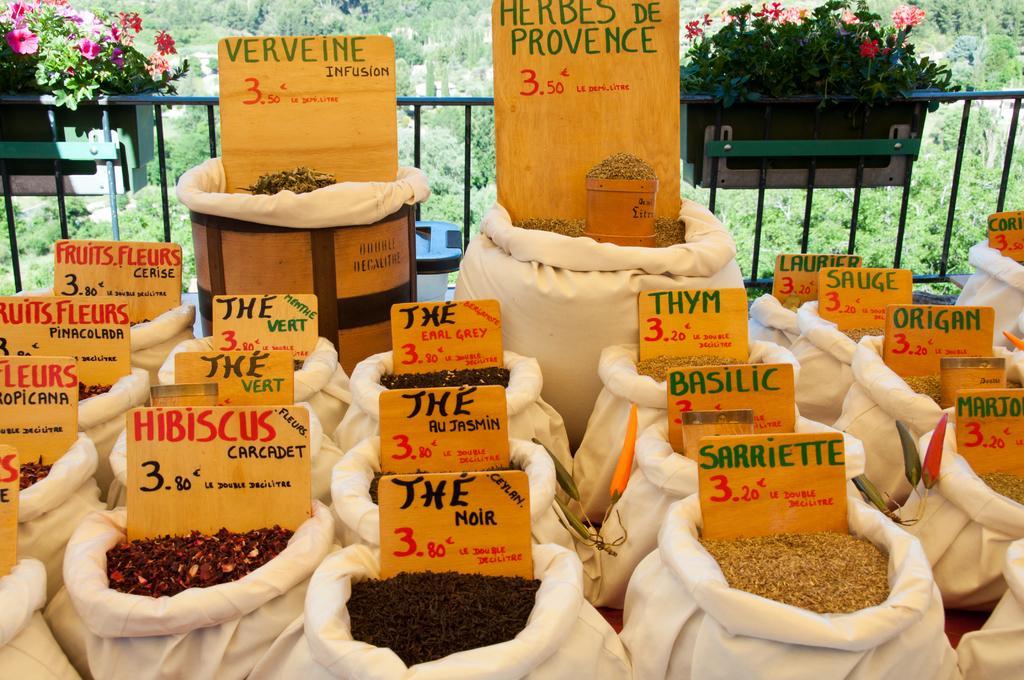Describe this image in one or two sentences. In this image there are some seeds and herbs in the bags with the name boards , and in the background there are plants with flowers, iron grills,trees,sky. 